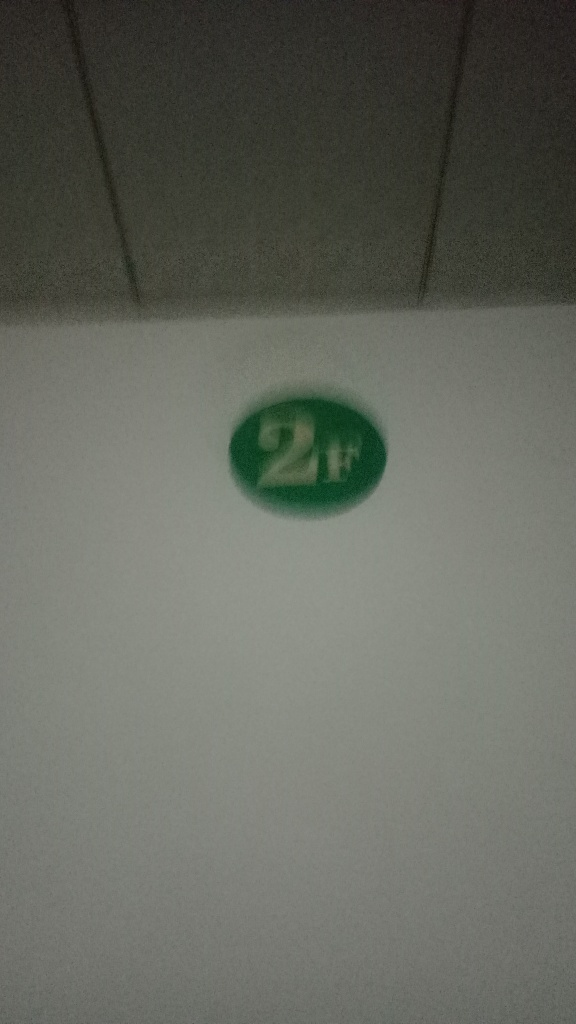What can you infer about the location where this image was taken? Inferences about the location from this image are limited due to the poor quality and lack of visible context. However, the presence of the '2H' marking could suggest that the image was taken within an institutional or organized setting, such as a school, office, or public building where rooms or areas are numbered or labeled for identification. It's also possible that the setting is an industrial or technical environment where the '2H' indicates a grading or category for materials or tools. 